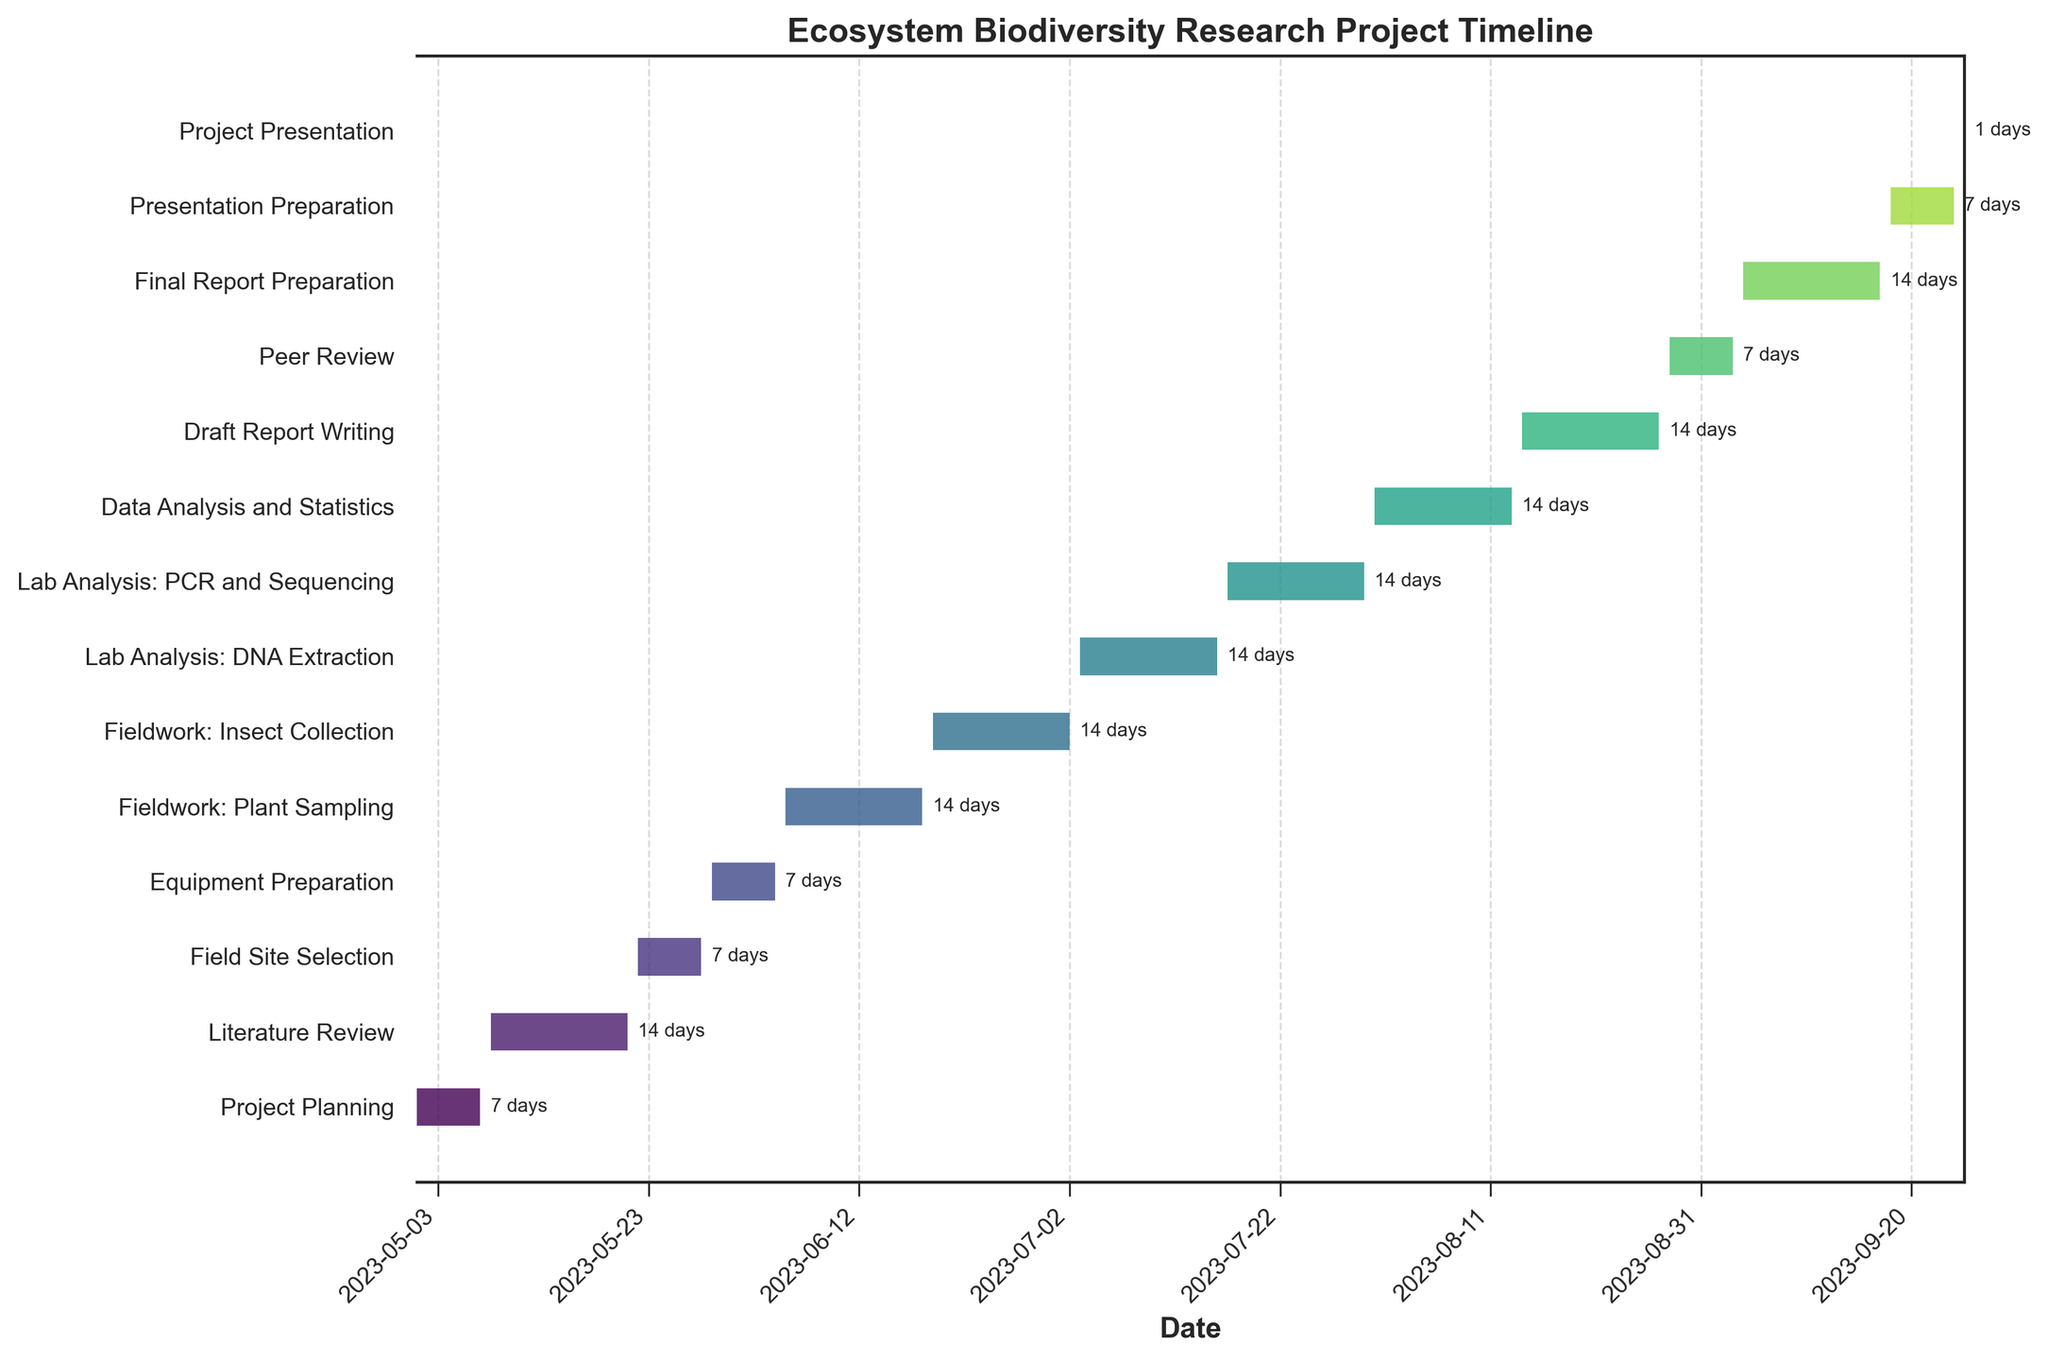What is the title of the figure? The title is usually found at the top of the figure and explains what the chart is about.
Answer: Ecosystem Biodiversity Research Project Timeline How long is the Fieldwork: Insect Collection phase? Check the duration annotation next to the Fieldwork: Insect Collection bar.
Answer: 14 days Which phase finishes first? Determine which task's bar ends the earliest date-wise on the x-axis.
Answer: Project Planning How many tasks last exactly 7 days? Calculate the number of bars that have a duration annotation of "7 days" next to them.
Answer: 5 tasks Between Fieldwork: Plant Sampling and Lab Analysis: DNA Extraction, which starts first and by how many days? Compare the start dates of both tasks and calculate the difference.
Answer: Fieldwork: Plant Sampling starts first by 28 days Which task immediately follows the Literature Review? Identify the task that starts on or after the Literature Review ends without any gap.
Answer: Field Site Selection How many phases include both a start and end date in the month of July? Count the tasks whose start and end dates fall within July.
Answer: 3 phases When does the Data Analysis and Statistics phase begin and end? Check the start and end annotations next to the Data Analysis and Statistics task bar.
Answer: July 31 to August 13 What is the total duration of all tasks combined? Sum the durations of all tasks given in days.
Answer: 139 days Identify two tasks that overlap in their duration and state the overlapping time period for each. Find two tasks with overlapping date ranges and calculate the overlap. For example, Fieldwork: Insect Collection and Equipment Preparation overlap partly in June.
Answer: Fieldwork: Insect Collection and Equipment Preparation overlap 7 days 